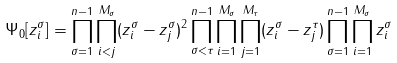<formula> <loc_0><loc_0><loc_500><loc_500>\Psi _ { 0 } [ z _ { i } ^ { \sigma } ] = \prod _ { \sigma = 1 } ^ { n - 1 } \prod ^ { M _ { \sigma } } _ { i < j } ( z _ { i } ^ { \sigma } - z _ { j } ^ { \sigma } ) ^ { 2 } \prod ^ { n - 1 } _ { \sigma < \tau } \prod _ { i = 1 } ^ { M _ { \sigma } } \prod _ { j = 1 } ^ { M _ { \tau } } ( z _ { i } ^ { \sigma } - z _ { j } ^ { \tau } ) \prod _ { \sigma = 1 } ^ { n - 1 } \prod _ { i = 1 } ^ { M _ { \sigma } } z _ { i } ^ { \sigma }</formula> 